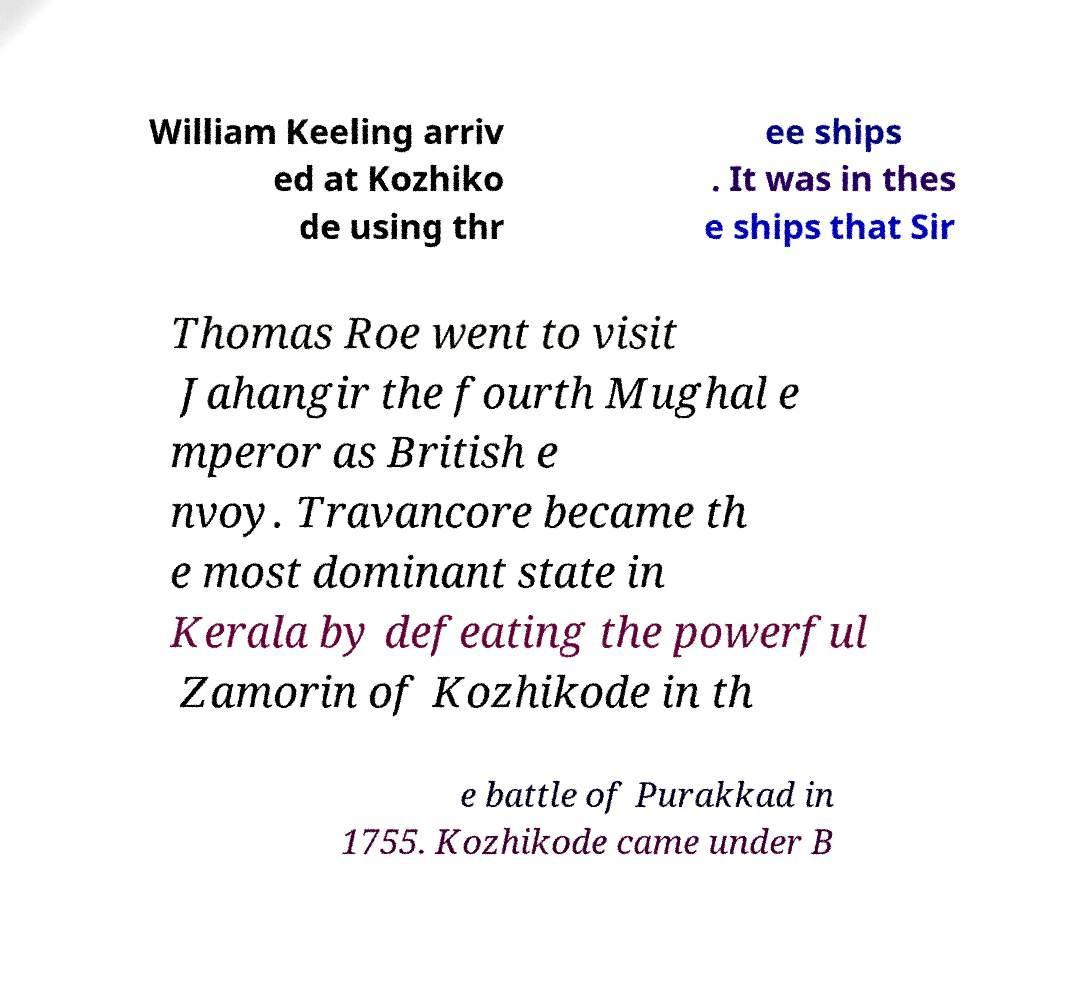There's text embedded in this image that I need extracted. Can you transcribe it verbatim? William Keeling arriv ed at Kozhiko de using thr ee ships . It was in thes e ships that Sir Thomas Roe went to visit Jahangir the fourth Mughal e mperor as British e nvoy. Travancore became th e most dominant state in Kerala by defeating the powerful Zamorin of Kozhikode in th e battle of Purakkad in 1755. Kozhikode came under B 